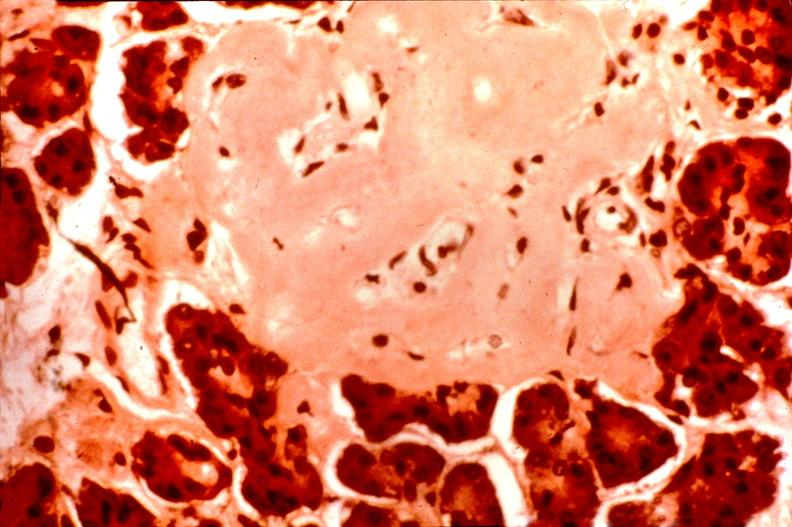what is present?
Answer the question using a single word or phrase. Endocrine 